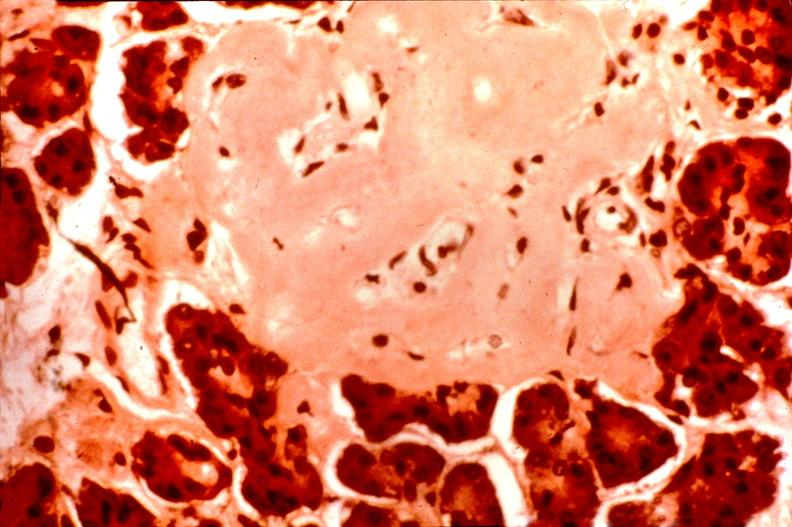what is present?
Answer the question using a single word or phrase. Endocrine 